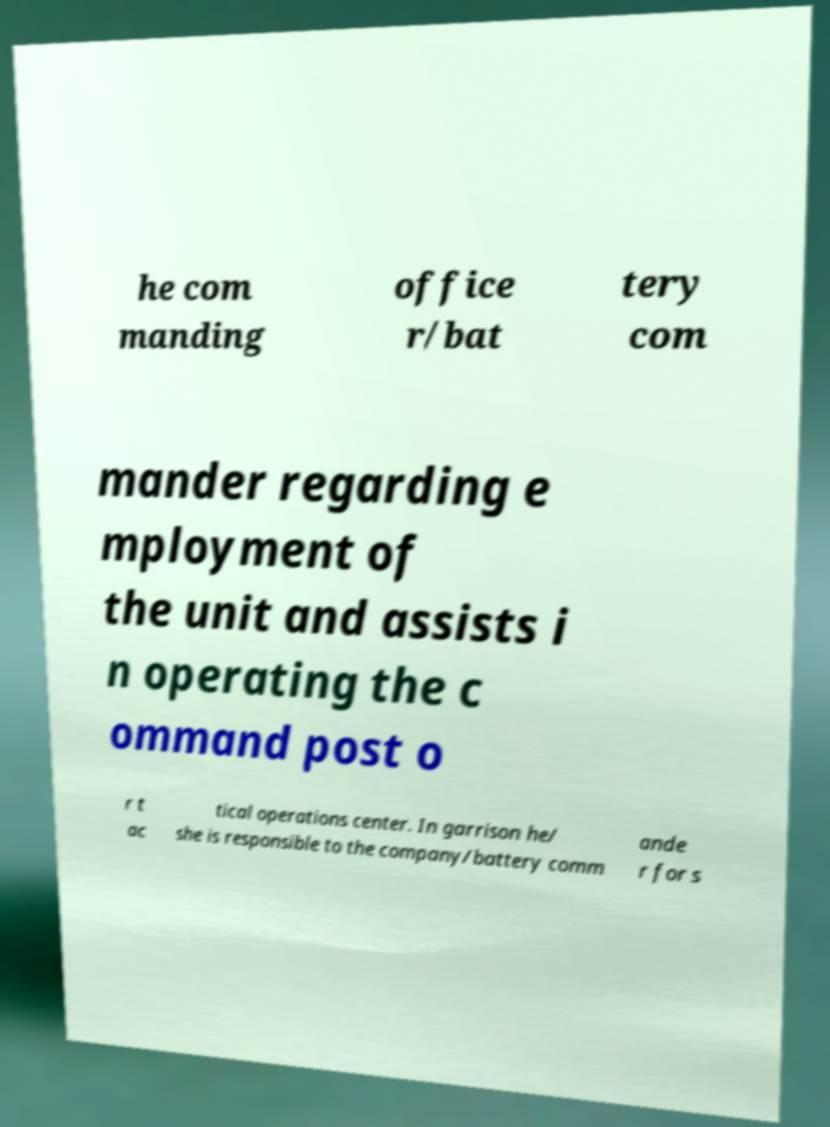Can you read and provide the text displayed in the image?This photo seems to have some interesting text. Can you extract and type it out for me? he com manding office r/bat tery com mander regarding e mployment of the unit and assists i n operating the c ommand post o r t ac tical operations center. In garrison he/ she is responsible to the company/battery comm ande r for s 